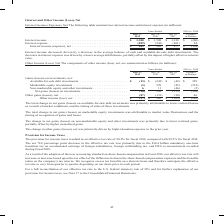According to Cisco Systems's financial document, Why did interest income decrease? driven by a decrease in the average balance of cash and available-for-sale debt investments.. The document states: "Interest income decreased, driven by a decrease in the average balance of cash and available-for-sale debt investments. The decrease in interest expen..." Also, Which years does the table provide information for interest income and interest expense? The document contains multiple relevant values: 2019, 2018, 2017. From the document: "019 vs. 2018 July 27, 2019 July 28, 2018 July 29, 2017 Variance in Dollars Interest income . $ 1,308 $ 1,508 $ 1,338 $ (200) Interest expense . (859) ..." Also, What was the interest expense in 2017? According to the financial document, (861) (in millions). The relevant text states: "508 $ 1,338 $ (200) Interest expense . (859) (943) (861) 84 Interest income (expense), net . $ 449 $ 565 $ 477 $ (116)..." Also, can you calculate: What was the change in Interest expense between 2017 and 2018? Based on the calculation: -943-(-861), the result is -82 (in millions). This is based on the information: "$ 1,508 $ 1,338 $ (200) Interest expense . (859) (943) (861) 84 Interest income (expense), net . $ 449 $ 565 $ 477 $ (116) 8 $ 1,338 $ (200) Interest expense . (859) (943) (861) 84 Interest income (ex..." The key data points involved are: 861, 943. Also, can you calculate: What was the change in Interest income between 2018 and 2019? Based on the calculation: 1,308-1,508, the result is -200 (in millions). This is based on the information: "7 Variance in Dollars Interest income . $ 1,308 $ 1,508 $ 1,338 $ (200) Interest expense . (859) (943) (861) 84 Interest income (expense), net . $ 449 $ 56 29, 2017 Variance in Dollars Interest income..." The key data points involved are: 1,308, 1,508. Also, can you calculate: What was the percentage change in the net interest income (expense) between 2018 and 2019? To answer this question, I need to perform calculations using the financial data. The calculation is: (449-565)/565, which equals -20.53 (percentage). This is based on the information: "(861) 84 Interest income (expense), net . $ 449 $ 565 $ 477 $ (116) (943) (861) 84 Interest income (expense), net . $ 449 $ 565 $ 477 $ (116)..." The key data points involved are: 449, 565. 